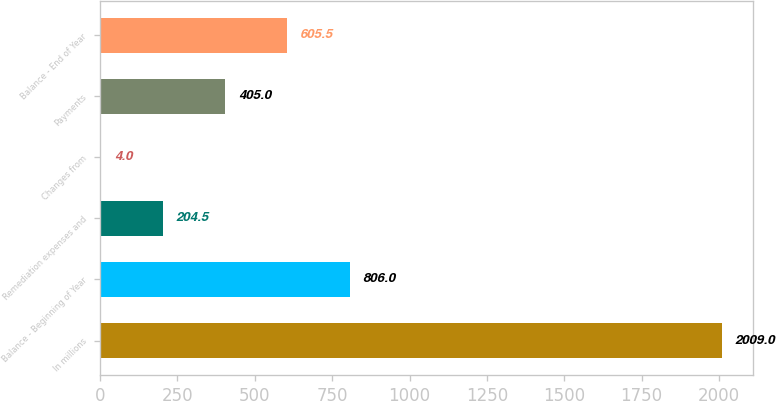Convert chart. <chart><loc_0><loc_0><loc_500><loc_500><bar_chart><fcel>In millions<fcel>Balance - Beginning of Year<fcel>Remediation expenses and<fcel>Changes from<fcel>Payments<fcel>Balance - End of Year<nl><fcel>2009<fcel>806<fcel>204.5<fcel>4<fcel>405<fcel>605.5<nl></chart> 